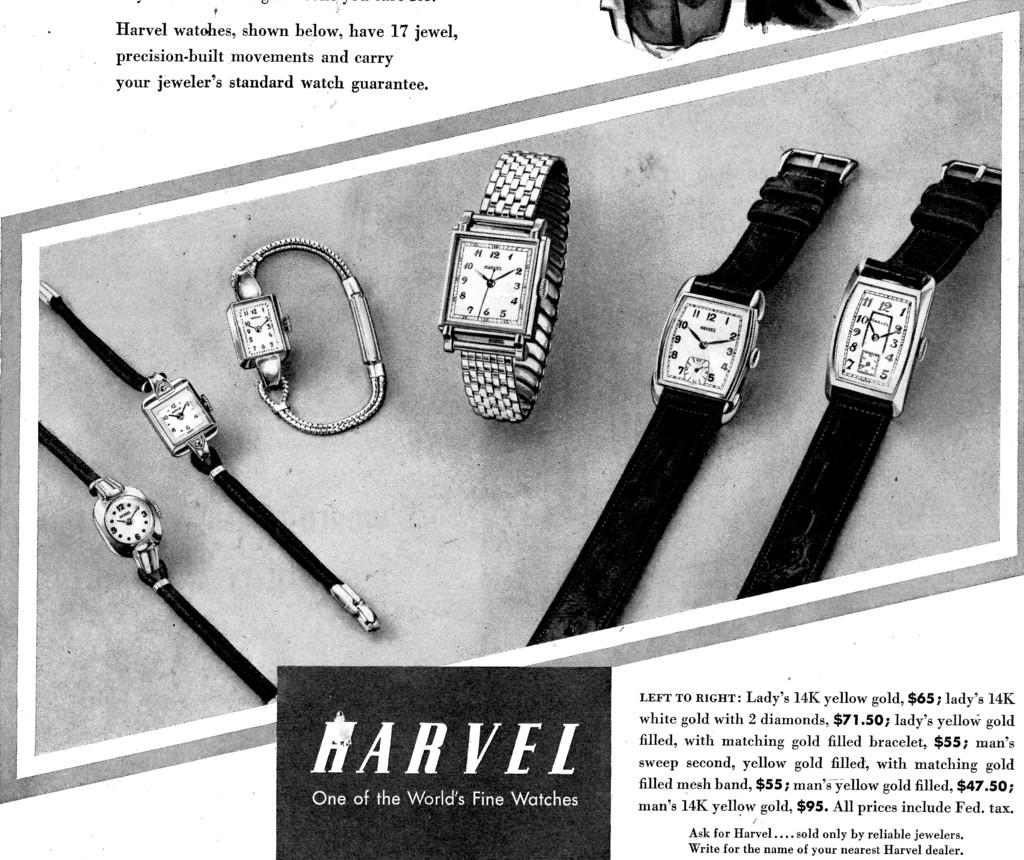Who made these watches?
Provide a short and direct response. Harvel. 